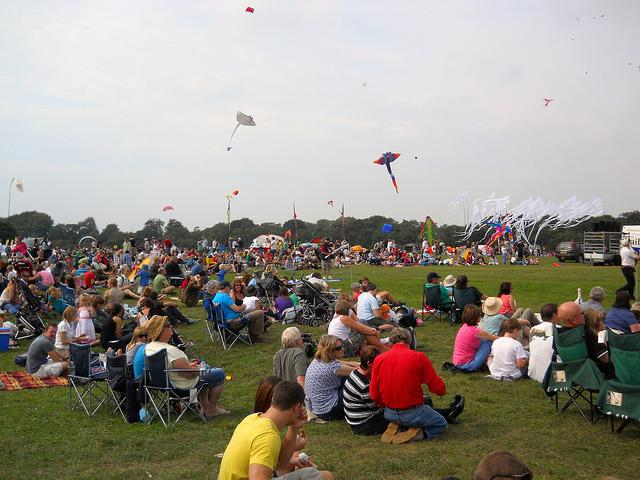Why are there more people than kites? show 